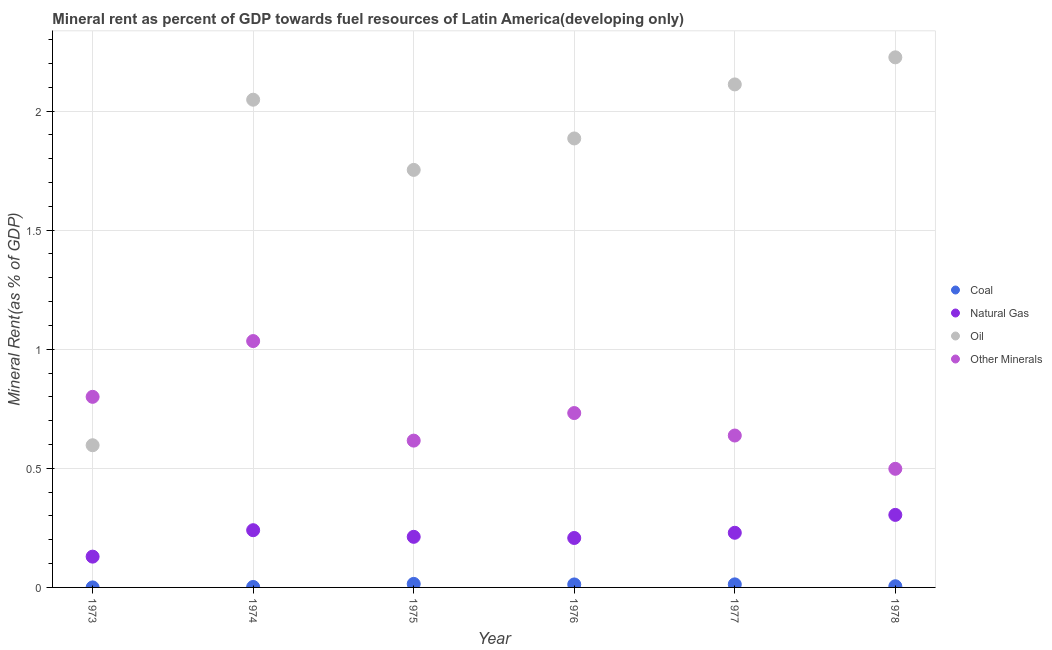Is the number of dotlines equal to the number of legend labels?
Provide a succinct answer. Yes. What is the oil rent in 1974?
Your response must be concise. 2.05. Across all years, what is the maximum  rent of other minerals?
Give a very brief answer. 1.03. Across all years, what is the minimum  rent of other minerals?
Ensure brevity in your answer.  0.5. In which year was the  rent of other minerals maximum?
Keep it short and to the point. 1974. In which year was the oil rent minimum?
Your answer should be compact. 1973. What is the total oil rent in the graph?
Keep it short and to the point. 10.62. What is the difference between the oil rent in 1976 and that in 1977?
Your response must be concise. -0.23. What is the difference between the coal rent in 1978 and the oil rent in 1973?
Ensure brevity in your answer.  -0.59. What is the average oil rent per year?
Keep it short and to the point. 1.77. In the year 1973, what is the difference between the  rent of other minerals and natural gas rent?
Offer a terse response. 0.67. In how many years, is the coal rent greater than 0.8 %?
Your answer should be compact. 0. What is the ratio of the oil rent in 1974 to that in 1976?
Provide a succinct answer. 1.09. Is the  rent of other minerals in 1976 less than that in 1977?
Your answer should be very brief. No. Is the difference between the natural gas rent in 1976 and 1977 greater than the difference between the oil rent in 1976 and 1977?
Offer a terse response. Yes. What is the difference between the highest and the second highest oil rent?
Provide a succinct answer. 0.11. What is the difference between the highest and the lowest natural gas rent?
Your response must be concise. 0.18. In how many years, is the  rent of other minerals greater than the average  rent of other minerals taken over all years?
Offer a very short reply. 3. Is the sum of the natural gas rent in 1976 and 1977 greater than the maximum coal rent across all years?
Offer a terse response. Yes. Is it the case that in every year, the sum of the coal rent and natural gas rent is greater than the oil rent?
Offer a very short reply. No. Does the  rent of other minerals monotonically increase over the years?
Your response must be concise. No. How many dotlines are there?
Offer a terse response. 4. Does the graph contain any zero values?
Offer a terse response. No. Where does the legend appear in the graph?
Make the answer very short. Center right. How are the legend labels stacked?
Offer a very short reply. Vertical. What is the title of the graph?
Ensure brevity in your answer.  Mineral rent as percent of GDP towards fuel resources of Latin America(developing only). What is the label or title of the X-axis?
Ensure brevity in your answer.  Year. What is the label or title of the Y-axis?
Make the answer very short. Mineral Rent(as % of GDP). What is the Mineral Rent(as % of GDP) in Coal in 1973?
Give a very brief answer. 2.93770621847752e-5. What is the Mineral Rent(as % of GDP) in Natural Gas in 1973?
Your response must be concise. 0.13. What is the Mineral Rent(as % of GDP) in Oil in 1973?
Ensure brevity in your answer.  0.6. What is the Mineral Rent(as % of GDP) in Other Minerals in 1973?
Offer a very short reply. 0.8. What is the Mineral Rent(as % of GDP) of Coal in 1974?
Ensure brevity in your answer.  0. What is the Mineral Rent(as % of GDP) in Natural Gas in 1974?
Provide a succinct answer. 0.24. What is the Mineral Rent(as % of GDP) of Oil in 1974?
Make the answer very short. 2.05. What is the Mineral Rent(as % of GDP) of Other Minerals in 1974?
Give a very brief answer. 1.03. What is the Mineral Rent(as % of GDP) in Coal in 1975?
Your response must be concise. 0.01. What is the Mineral Rent(as % of GDP) in Natural Gas in 1975?
Ensure brevity in your answer.  0.21. What is the Mineral Rent(as % of GDP) of Oil in 1975?
Provide a succinct answer. 1.75. What is the Mineral Rent(as % of GDP) in Other Minerals in 1975?
Provide a succinct answer. 0.62. What is the Mineral Rent(as % of GDP) in Coal in 1976?
Keep it short and to the point. 0.01. What is the Mineral Rent(as % of GDP) in Natural Gas in 1976?
Give a very brief answer. 0.21. What is the Mineral Rent(as % of GDP) in Oil in 1976?
Your answer should be compact. 1.89. What is the Mineral Rent(as % of GDP) in Other Minerals in 1976?
Offer a terse response. 0.73. What is the Mineral Rent(as % of GDP) of Coal in 1977?
Ensure brevity in your answer.  0.01. What is the Mineral Rent(as % of GDP) of Natural Gas in 1977?
Your response must be concise. 0.23. What is the Mineral Rent(as % of GDP) in Oil in 1977?
Provide a succinct answer. 2.11. What is the Mineral Rent(as % of GDP) of Other Minerals in 1977?
Your answer should be compact. 0.64. What is the Mineral Rent(as % of GDP) in Coal in 1978?
Your answer should be compact. 0. What is the Mineral Rent(as % of GDP) in Natural Gas in 1978?
Keep it short and to the point. 0.3. What is the Mineral Rent(as % of GDP) of Oil in 1978?
Keep it short and to the point. 2.23. What is the Mineral Rent(as % of GDP) of Other Minerals in 1978?
Offer a very short reply. 0.5. Across all years, what is the maximum Mineral Rent(as % of GDP) in Coal?
Your answer should be compact. 0.01. Across all years, what is the maximum Mineral Rent(as % of GDP) in Natural Gas?
Provide a succinct answer. 0.3. Across all years, what is the maximum Mineral Rent(as % of GDP) of Oil?
Make the answer very short. 2.23. Across all years, what is the maximum Mineral Rent(as % of GDP) in Other Minerals?
Offer a very short reply. 1.03. Across all years, what is the minimum Mineral Rent(as % of GDP) in Coal?
Your answer should be compact. 2.93770621847752e-5. Across all years, what is the minimum Mineral Rent(as % of GDP) in Natural Gas?
Offer a terse response. 0.13. Across all years, what is the minimum Mineral Rent(as % of GDP) of Oil?
Your answer should be very brief. 0.6. Across all years, what is the minimum Mineral Rent(as % of GDP) in Other Minerals?
Provide a short and direct response. 0.5. What is the total Mineral Rent(as % of GDP) in Coal in the graph?
Ensure brevity in your answer.  0.05. What is the total Mineral Rent(as % of GDP) of Natural Gas in the graph?
Offer a terse response. 1.32. What is the total Mineral Rent(as % of GDP) of Oil in the graph?
Give a very brief answer. 10.62. What is the total Mineral Rent(as % of GDP) of Other Minerals in the graph?
Your answer should be very brief. 4.32. What is the difference between the Mineral Rent(as % of GDP) of Coal in 1973 and that in 1974?
Provide a short and direct response. -0. What is the difference between the Mineral Rent(as % of GDP) of Natural Gas in 1973 and that in 1974?
Make the answer very short. -0.11. What is the difference between the Mineral Rent(as % of GDP) of Oil in 1973 and that in 1974?
Make the answer very short. -1.45. What is the difference between the Mineral Rent(as % of GDP) in Other Minerals in 1973 and that in 1974?
Make the answer very short. -0.23. What is the difference between the Mineral Rent(as % of GDP) of Coal in 1973 and that in 1975?
Your answer should be compact. -0.01. What is the difference between the Mineral Rent(as % of GDP) of Natural Gas in 1973 and that in 1975?
Give a very brief answer. -0.08. What is the difference between the Mineral Rent(as % of GDP) of Oil in 1973 and that in 1975?
Keep it short and to the point. -1.16. What is the difference between the Mineral Rent(as % of GDP) of Other Minerals in 1973 and that in 1975?
Give a very brief answer. 0.18. What is the difference between the Mineral Rent(as % of GDP) of Coal in 1973 and that in 1976?
Make the answer very short. -0.01. What is the difference between the Mineral Rent(as % of GDP) in Natural Gas in 1973 and that in 1976?
Your answer should be very brief. -0.08. What is the difference between the Mineral Rent(as % of GDP) in Oil in 1973 and that in 1976?
Give a very brief answer. -1.29. What is the difference between the Mineral Rent(as % of GDP) in Other Minerals in 1973 and that in 1976?
Offer a very short reply. 0.07. What is the difference between the Mineral Rent(as % of GDP) in Coal in 1973 and that in 1977?
Give a very brief answer. -0.01. What is the difference between the Mineral Rent(as % of GDP) of Natural Gas in 1973 and that in 1977?
Make the answer very short. -0.1. What is the difference between the Mineral Rent(as % of GDP) of Oil in 1973 and that in 1977?
Ensure brevity in your answer.  -1.51. What is the difference between the Mineral Rent(as % of GDP) of Other Minerals in 1973 and that in 1977?
Your answer should be compact. 0.16. What is the difference between the Mineral Rent(as % of GDP) of Coal in 1973 and that in 1978?
Ensure brevity in your answer.  -0. What is the difference between the Mineral Rent(as % of GDP) of Natural Gas in 1973 and that in 1978?
Keep it short and to the point. -0.18. What is the difference between the Mineral Rent(as % of GDP) in Oil in 1973 and that in 1978?
Keep it short and to the point. -1.63. What is the difference between the Mineral Rent(as % of GDP) of Other Minerals in 1973 and that in 1978?
Make the answer very short. 0.3. What is the difference between the Mineral Rent(as % of GDP) in Coal in 1974 and that in 1975?
Provide a short and direct response. -0.01. What is the difference between the Mineral Rent(as % of GDP) of Natural Gas in 1974 and that in 1975?
Offer a very short reply. 0.03. What is the difference between the Mineral Rent(as % of GDP) of Oil in 1974 and that in 1975?
Give a very brief answer. 0.29. What is the difference between the Mineral Rent(as % of GDP) of Other Minerals in 1974 and that in 1975?
Give a very brief answer. 0.42. What is the difference between the Mineral Rent(as % of GDP) of Coal in 1974 and that in 1976?
Your answer should be very brief. -0.01. What is the difference between the Mineral Rent(as % of GDP) in Natural Gas in 1974 and that in 1976?
Provide a succinct answer. 0.03. What is the difference between the Mineral Rent(as % of GDP) in Oil in 1974 and that in 1976?
Keep it short and to the point. 0.16. What is the difference between the Mineral Rent(as % of GDP) in Other Minerals in 1974 and that in 1976?
Keep it short and to the point. 0.3. What is the difference between the Mineral Rent(as % of GDP) of Coal in 1974 and that in 1977?
Offer a terse response. -0.01. What is the difference between the Mineral Rent(as % of GDP) in Natural Gas in 1974 and that in 1977?
Your response must be concise. 0.01. What is the difference between the Mineral Rent(as % of GDP) in Oil in 1974 and that in 1977?
Keep it short and to the point. -0.06. What is the difference between the Mineral Rent(as % of GDP) in Other Minerals in 1974 and that in 1977?
Your answer should be compact. 0.4. What is the difference between the Mineral Rent(as % of GDP) of Coal in 1974 and that in 1978?
Make the answer very short. -0. What is the difference between the Mineral Rent(as % of GDP) of Natural Gas in 1974 and that in 1978?
Your answer should be compact. -0.06. What is the difference between the Mineral Rent(as % of GDP) in Oil in 1974 and that in 1978?
Ensure brevity in your answer.  -0.18. What is the difference between the Mineral Rent(as % of GDP) of Other Minerals in 1974 and that in 1978?
Make the answer very short. 0.54. What is the difference between the Mineral Rent(as % of GDP) in Coal in 1975 and that in 1976?
Offer a terse response. 0. What is the difference between the Mineral Rent(as % of GDP) of Natural Gas in 1975 and that in 1976?
Provide a short and direct response. 0. What is the difference between the Mineral Rent(as % of GDP) in Oil in 1975 and that in 1976?
Your answer should be very brief. -0.13. What is the difference between the Mineral Rent(as % of GDP) in Other Minerals in 1975 and that in 1976?
Keep it short and to the point. -0.12. What is the difference between the Mineral Rent(as % of GDP) of Coal in 1975 and that in 1977?
Ensure brevity in your answer.  0. What is the difference between the Mineral Rent(as % of GDP) of Natural Gas in 1975 and that in 1977?
Keep it short and to the point. -0.02. What is the difference between the Mineral Rent(as % of GDP) in Oil in 1975 and that in 1977?
Give a very brief answer. -0.36. What is the difference between the Mineral Rent(as % of GDP) in Other Minerals in 1975 and that in 1977?
Your response must be concise. -0.02. What is the difference between the Mineral Rent(as % of GDP) in Coal in 1975 and that in 1978?
Your response must be concise. 0.01. What is the difference between the Mineral Rent(as % of GDP) in Natural Gas in 1975 and that in 1978?
Offer a very short reply. -0.09. What is the difference between the Mineral Rent(as % of GDP) in Oil in 1975 and that in 1978?
Your answer should be compact. -0.47. What is the difference between the Mineral Rent(as % of GDP) in Other Minerals in 1975 and that in 1978?
Offer a very short reply. 0.12. What is the difference between the Mineral Rent(as % of GDP) in Coal in 1976 and that in 1977?
Ensure brevity in your answer.  -0. What is the difference between the Mineral Rent(as % of GDP) in Natural Gas in 1976 and that in 1977?
Keep it short and to the point. -0.02. What is the difference between the Mineral Rent(as % of GDP) in Oil in 1976 and that in 1977?
Offer a very short reply. -0.23. What is the difference between the Mineral Rent(as % of GDP) of Other Minerals in 1976 and that in 1977?
Your answer should be compact. 0.09. What is the difference between the Mineral Rent(as % of GDP) in Coal in 1976 and that in 1978?
Provide a short and direct response. 0.01. What is the difference between the Mineral Rent(as % of GDP) of Natural Gas in 1976 and that in 1978?
Keep it short and to the point. -0.1. What is the difference between the Mineral Rent(as % of GDP) in Oil in 1976 and that in 1978?
Offer a very short reply. -0.34. What is the difference between the Mineral Rent(as % of GDP) in Other Minerals in 1976 and that in 1978?
Offer a very short reply. 0.23. What is the difference between the Mineral Rent(as % of GDP) in Coal in 1977 and that in 1978?
Offer a terse response. 0.01. What is the difference between the Mineral Rent(as % of GDP) in Natural Gas in 1977 and that in 1978?
Your response must be concise. -0.08. What is the difference between the Mineral Rent(as % of GDP) in Oil in 1977 and that in 1978?
Provide a succinct answer. -0.11. What is the difference between the Mineral Rent(as % of GDP) in Other Minerals in 1977 and that in 1978?
Your answer should be compact. 0.14. What is the difference between the Mineral Rent(as % of GDP) in Coal in 1973 and the Mineral Rent(as % of GDP) in Natural Gas in 1974?
Your answer should be compact. -0.24. What is the difference between the Mineral Rent(as % of GDP) in Coal in 1973 and the Mineral Rent(as % of GDP) in Oil in 1974?
Your answer should be very brief. -2.05. What is the difference between the Mineral Rent(as % of GDP) of Coal in 1973 and the Mineral Rent(as % of GDP) of Other Minerals in 1974?
Keep it short and to the point. -1.03. What is the difference between the Mineral Rent(as % of GDP) of Natural Gas in 1973 and the Mineral Rent(as % of GDP) of Oil in 1974?
Provide a short and direct response. -1.92. What is the difference between the Mineral Rent(as % of GDP) of Natural Gas in 1973 and the Mineral Rent(as % of GDP) of Other Minerals in 1974?
Provide a succinct answer. -0.91. What is the difference between the Mineral Rent(as % of GDP) of Oil in 1973 and the Mineral Rent(as % of GDP) of Other Minerals in 1974?
Provide a short and direct response. -0.44. What is the difference between the Mineral Rent(as % of GDP) of Coal in 1973 and the Mineral Rent(as % of GDP) of Natural Gas in 1975?
Give a very brief answer. -0.21. What is the difference between the Mineral Rent(as % of GDP) in Coal in 1973 and the Mineral Rent(as % of GDP) in Oil in 1975?
Give a very brief answer. -1.75. What is the difference between the Mineral Rent(as % of GDP) in Coal in 1973 and the Mineral Rent(as % of GDP) in Other Minerals in 1975?
Provide a succinct answer. -0.62. What is the difference between the Mineral Rent(as % of GDP) in Natural Gas in 1973 and the Mineral Rent(as % of GDP) in Oil in 1975?
Offer a very short reply. -1.62. What is the difference between the Mineral Rent(as % of GDP) in Natural Gas in 1973 and the Mineral Rent(as % of GDP) in Other Minerals in 1975?
Offer a terse response. -0.49. What is the difference between the Mineral Rent(as % of GDP) in Oil in 1973 and the Mineral Rent(as % of GDP) in Other Minerals in 1975?
Keep it short and to the point. -0.02. What is the difference between the Mineral Rent(as % of GDP) in Coal in 1973 and the Mineral Rent(as % of GDP) in Natural Gas in 1976?
Offer a very short reply. -0.21. What is the difference between the Mineral Rent(as % of GDP) in Coal in 1973 and the Mineral Rent(as % of GDP) in Oil in 1976?
Provide a short and direct response. -1.89. What is the difference between the Mineral Rent(as % of GDP) in Coal in 1973 and the Mineral Rent(as % of GDP) in Other Minerals in 1976?
Ensure brevity in your answer.  -0.73. What is the difference between the Mineral Rent(as % of GDP) of Natural Gas in 1973 and the Mineral Rent(as % of GDP) of Oil in 1976?
Make the answer very short. -1.76. What is the difference between the Mineral Rent(as % of GDP) in Natural Gas in 1973 and the Mineral Rent(as % of GDP) in Other Minerals in 1976?
Your response must be concise. -0.6. What is the difference between the Mineral Rent(as % of GDP) of Oil in 1973 and the Mineral Rent(as % of GDP) of Other Minerals in 1976?
Provide a succinct answer. -0.14. What is the difference between the Mineral Rent(as % of GDP) in Coal in 1973 and the Mineral Rent(as % of GDP) in Natural Gas in 1977?
Your response must be concise. -0.23. What is the difference between the Mineral Rent(as % of GDP) in Coal in 1973 and the Mineral Rent(as % of GDP) in Oil in 1977?
Your answer should be very brief. -2.11. What is the difference between the Mineral Rent(as % of GDP) of Coal in 1973 and the Mineral Rent(as % of GDP) of Other Minerals in 1977?
Offer a terse response. -0.64. What is the difference between the Mineral Rent(as % of GDP) of Natural Gas in 1973 and the Mineral Rent(as % of GDP) of Oil in 1977?
Provide a short and direct response. -1.98. What is the difference between the Mineral Rent(as % of GDP) of Natural Gas in 1973 and the Mineral Rent(as % of GDP) of Other Minerals in 1977?
Ensure brevity in your answer.  -0.51. What is the difference between the Mineral Rent(as % of GDP) of Oil in 1973 and the Mineral Rent(as % of GDP) of Other Minerals in 1977?
Your response must be concise. -0.04. What is the difference between the Mineral Rent(as % of GDP) of Coal in 1973 and the Mineral Rent(as % of GDP) of Natural Gas in 1978?
Provide a short and direct response. -0.3. What is the difference between the Mineral Rent(as % of GDP) of Coal in 1973 and the Mineral Rent(as % of GDP) of Oil in 1978?
Provide a succinct answer. -2.23. What is the difference between the Mineral Rent(as % of GDP) in Coal in 1973 and the Mineral Rent(as % of GDP) in Other Minerals in 1978?
Offer a very short reply. -0.5. What is the difference between the Mineral Rent(as % of GDP) of Natural Gas in 1973 and the Mineral Rent(as % of GDP) of Oil in 1978?
Your response must be concise. -2.1. What is the difference between the Mineral Rent(as % of GDP) in Natural Gas in 1973 and the Mineral Rent(as % of GDP) in Other Minerals in 1978?
Your answer should be very brief. -0.37. What is the difference between the Mineral Rent(as % of GDP) of Oil in 1973 and the Mineral Rent(as % of GDP) of Other Minerals in 1978?
Provide a short and direct response. 0.1. What is the difference between the Mineral Rent(as % of GDP) in Coal in 1974 and the Mineral Rent(as % of GDP) in Natural Gas in 1975?
Provide a short and direct response. -0.21. What is the difference between the Mineral Rent(as % of GDP) in Coal in 1974 and the Mineral Rent(as % of GDP) in Oil in 1975?
Your answer should be very brief. -1.75. What is the difference between the Mineral Rent(as % of GDP) in Coal in 1974 and the Mineral Rent(as % of GDP) in Other Minerals in 1975?
Ensure brevity in your answer.  -0.61. What is the difference between the Mineral Rent(as % of GDP) of Natural Gas in 1974 and the Mineral Rent(as % of GDP) of Oil in 1975?
Offer a very short reply. -1.51. What is the difference between the Mineral Rent(as % of GDP) in Natural Gas in 1974 and the Mineral Rent(as % of GDP) in Other Minerals in 1975?
Offer a very short reply. -0.38. What is the difference between the Mineral Rent(as % of GDP) of Oil in 1974 and the Mineral Rent(as % of GDP) of Other Minerals in 1975?
Give a very brief answer. 1.43. What is the difference between the Mineral Rent(as % of GDP) of Coal in 1974 and the Mineral Rent(as % of GDP) of Natural Gas in 1976?
Provide a short and direct response. -0.21. What is the difference between the Mineral Rent(as % of GDP) in Coal in 1974 and the Mineral Rent(as % of GDP) in Oil in 1976?
Give a very brief answer. -1.88. What is the difference between the Mineral Rent(as % of GDP) of Coal in 1974 and the Mineral Rent(as % of GDP) of Other Minerals in 1976?
Provide a succinct answer. -0.73. What is the difference between the Mineral Rent(as % of GDP) in Natural Gas in 1974 and the Mineral Rent(as % of GDP) in Oil in 1976?
Provide a succinct answer. -1.64. What is the difference between the Mineral Rent(as % of GDP) of Natural Gas in 1974 and the Mineral Rent(as % of GDP) of Other Minerals in 1976?
Your answer should be compact. -0.49. What is the difference between the Mineral Rent(as % of GDP) of Oil in 1974 and the Mineral Rent(as % of GDP) of Other Minerals in 1976?
Offer a terse response. 1.32. What is the difference between the Mineral Rent(as % of GDP) of Coal in 1974 and the Mineral Rent(as % of GDP) of Natural Gas in 1977?
Keep it short and to the point. -0.23. What is the difference between the Mineral Rent(as % of GDP) of Coal in 1974 and the Mineral Rent(as % of GDP) of Oil in 1977?
Your answer should be compact. -2.11. What is the difference between the Mineral Rent(as % of GDP) in Coal in 1974 and the Mineral Rent(as % of GDP) in Other Minerals in 1977?
Keep it short and to the point. -0.64. What is the difference between the Mineral Rent(as % of GDP) in Natural Gas in 1974 and the Mineral Rent(as % of GDP) in Oil in 1977?
Give a very brief answer. -1.87. What is the difference between the Mineral Rent(as % of GDP) in Natural Gas in 1974 and the Mineral Rent(as % of GDP) in Other Minerals in 1977?
Provide a short and direct response. -0.4. What is the difference between the Mineral Rent(as % of GDP) in Oil in 1974 and the Mineral Rent(as % of GDP) in Other Minerals in 1977?
Your answer should be very brief. 1.41. What is the difference between the Mineral Rent(as % of GDP) in Coal in 1974 and the Mineral Rent(as % of GDP) in Natural Gas in 1978?
Provide a short and direct response. -0.3. What is the difference between the Mineral Rent(as % of GDP) in Coal in 1974 and the Mineral Rent(as % of GDP) in Oil in 1978?
Provide a succinct answer. -2.22. What is the difference between the Mineral Rent(as % of GDP) in Coal in 1974 and the Mineral Rent(as % of GDP) in Other Minerals in 1978?
Your response must be concise. -0.5. What is the difference between the Mineral Rent(as % of GDP) in Natural Gas in 1974 and the Mineral Rent(as % of GDP) in Oil in 1978?
Offer a very short reply. -1.99. What is the difference between the Mineral Rent(as % of GDP) of Natural Gas in 1974 and the Mineral Rent(as % of GDP) of Other Minerals in 1978?
Provide a short and direct response. -0.26. What is the difference between the Mineral Rent(as % of GDP) in Oil in 1974 and the Mineral Rent(as % of GDP) in Other Minerals in 1978?
Offer a terse response. 1.55. What is the difference between the Mineral Rent(as % of GDP) of Coal in 1975 and the Mineral Rent(as % of GDP) of Natural Gas in 1976?
Make the answer very short. -0.19. What is the difference between the Mineral Rent(as % of GDP) in Coal in 1975 and the Mineral Rent(as % of GDP) in Oil in 1976?
Offer a very short reply. -1.87. What is the difference between the Mineral Rent(as % of GDP) in Coal in 1975 and the Mineral Rent(as % of GDP) in Other Minerals in 1976?
Your answer should be compact. -0.72. What is the difference between the Mineral Rent(as % of GDP) in Natural Gas in 1975 and the Mineral Rent(as % of GDP) in Oil in 1976?
Provide a succinct answer. -1.67. What is the difference between the Mineral Rent(as % of GDP) of Natural Gas in 1975 and the Mineral Rent(as % of GDP) of Other Minerals in 1976?
Offer a very short reply. -0.52. What is the difference between the Mineral Rent(as % of GDP) of Oil in 1975 and the Mineral Rent(as % of GDP) of Other Minerals in 1976?
Your response must be concise. 1.02. What is the difference between the Mineral Rent(as % of GDP) in Coal in 1975 and the Mineral Rent(as % of GDP) in Natural Gas in 1977?
Provide a short and direct response. -0.21. What is the difference between the Mineral Rent(as % of GDP) in Coal in 1975 and the Mineral Rent(as % of GDP) in Oil in 1977?
Give a very brief answer. -2.1. What is the difference between the Mineral Rent(as % of GDP) of Coal in 1975 and the Mineral Rent(as % of GDP) of Other Minerals in 1977?
Offer a terse response. -0.62. What is the difference between the Mineral Rent(as % of GDP) of Natural Gas in 1975 and the Mineral Rent(as % of GDP) of Oil in 1977?
Provide a short and direct response. -1.9. What is the difference between the Mineral Rent(as % of GDP) of Natural Gas in 1975 and the Mineral Rent(as % of GDP) of Other Minerals in 1977?
Your response must be concise. -0.43. What is the difference between the Mineral Rent(as % of GDP) in Oil in 1975 and the Mineral Rent(as % of GDP) in Other Minerals in 1977?
Provide a succinct answer. 1.12. What is the difference between the Mineral Rent(as % of GDP) in Coal in 1975 and the Mineral Rent(as % of GDP) in Natural Gas in 1978?
Give a very brief answer. -0.29. What is the difference between the Mineral Rent(as % of GDP) of Coal in 1975 and the Mineral Rent(as % of GDP) of Oil in 1978?
Offer a terse response. -2.21. What is the difference between the Mineral Rent(as % of GDP) in Coal in 1975 and the Mineral Rent(as % of GDP) in Other Minerals in 1978?
Your response must be concise. -0.48. What is the difference between the Mineral Rent(as % of GDP) of Natural Gas in 1975 and the Mineral Rent(as % of GDP) of Oil in 1978?
Offer a terse response. -2.01. What is the difference between the Mineral Rent(as % of GDP) of Natural Gas in 1975 and the Mineral Rent(as % of GDP) of Other Minerals in 1978?
Your answer should be very brief. -0.29. What is the difference between the Mineral Rent(as % of GDP) in Oil in 1975 and the Mineral Rent(as % of GDP) in Other Minerals in 1978?
Provide a succinct answer. 1.25. What is the difference between the Mineral Rent(as % of GDP) in Coal in 1976 and the Mineral Rent(as % of GDP) in Natural Gas in 1977?
Your response must be concise. -0.22. What is the difference between the Mineral Rent(as % of GDP) of Coal in 1976 and the Mineral Rent(as % of GDP) of Oil in 1977?
Make the answer very short. -2.1. What is the difference between the Mineral Rent(as % of GDP) in Coal in 1976 and the Mineral Rent(as % of GDP) in Other Minerals in 1977?
Give a very brief answer. -0.63. What is the difference between the Mineral Rent(as % of GDP) in Natural Gas in 1976 and the Mineral Rent(as % of GDP) in Oil in 1977?
Make the answer very short. -1.9. What is the difference between the Mineral Rent(as % of GDP) in Natural Gas in 1976 and the Mineral Rent(as % of GDP) in Other Minerals in 1977?
Your answer should be very brief. -0.43. What is the difference between the Mineral Rent(as % of GDP) in Oil in 1976 and the Mineral Rent(as % of GDP) in Other Minerals in 1977?
Make the answer very short. 1.25. What is the difference between the Mineral Rent(as % of GDP) in Coal in 1976 and the Mineral Rent(as % of GDP) in Natural Gas in 1978?
Give a very brief answer. -0.29. What is the difference between the Mineral Rent(as % of GDP) in Coal in 1976 and the Mineral Rent(as % of GDP) in Oil in 1978?
Make the answer very short. -2.21. What is the difference between the Mineral Rent(as % of GDP) in Coal in 1976 and the Mineral Rent(as % of GDP) in Other Minerals in 1978?
Offer a very short reply. -0.49. What is the difference between the Mineral Rent(as % of GDP) of Natural Gas in 1976 and the Mineral Rent(as % of GDP) of Oil in 1978?
Your answer should be very brief. -2.02. What is the difference between the Mineral Rent(as % of GDP) of Natural Gas in 1976 and the Mineral Rent(as % of GDP) of Other Minerals in 1978?
Offer a terse response. -0.29. What is the difference between the Mineral Rent(as % of GDP) of Oil in 1976 and the Mineral Rent(as % of GDP) of Other Minerals in 1978?
Give a very brief answer. 1.39. What is the difference between the Mineral Rent(as % of GDP) in Coal in 1977 and the Mineral Rent(as % of GDP) in Natural Gas in 1978?
Offer a very short reply. -0.29. What is the difference between the Mineral Rent(as % of GDP) of Coal in 1977 and the Mineral Rent(as % of GDP) of Oil in 1978?
Your answer should be compact. -2.21. What is the difference between the Mineral Rent(as % of GDP) in Coal in 1977 and the Mineral Rent(as % of GDP) in Other Minerals in 1978?
Offer a terse response. -0.49. What is the difference between the Mineral Rent(as % of GDP) of Natural Gas in 1977 and the Mineral Rent(as % of GDP) of Oil in 1978?
Provide a succinct answer. -2. What is the difference between the Mineral Rent(as % of GDP) in Natural Gas in 1977 and the Mineral Rent(as % of GDP) in Other Minerals in 1978?
Offer a terse response. -0.27. What is the difference between the Mineral Rent(as % of GDP) of Oil in 1977 and the Mineral Rent(as % of GDP) of Other Minerals in 1978?
Your answer should be compact. 1.61. What is the average Mineral Rent(as % of GDP) in Coal per year?
Your answer should be very brief. 0.01. What is the average Mineral Rent(as % of GDP) of Natural Gas per year?
Your answer should be compact. 0.22. What is the average Mineral Rent(as % of GDP) in Oil per year?
Give a very brief answer. 1.77. What is the average Mineral Rent(as % of GDP) in Other Minerals per year?
Keep it short and to the point. 0.72. In the year 1973, what is the difference between the Mineral Rent(as % of GDP) of Coal and Mineral Rent(as % of GDP) of Natural Gas?
Your answer should be compact. -0.13. In the year 1973, what is the difference between the Mineral Rent(as % of GDP) of Coal and Mineral Rent(as % of GDP) of Oil?
Offer a terse response. -0.6. In the year 1973, what is the difference between the Mineral Rent(as % of GDP) in Coal and Mineral Rent(as % of GDP) in Other Minerals?
Your answer should be compact. -0.8. In the year 1973, what is the difference between the Mineral Rent(as % of GDP) of Natural Gas and Mineral Rent(as % of GDP) of Oil?
Keep it short and to the point. -0.47. In the year 1973, what is the difference between the Mineral Rent(as % of GDP) in Natural Gas and Mineral Rent(as % of GDP) in Other Minerals?
Offer a terse response. -0.67. In the year 1973, what is the difference between the Mineral Rent(as % of GDP) in Oil and Mineral Rent(as % of GDP) in Other Minerals?
Provide a succinct answer. -0.2. In the year 1974, what is the difference between the Mineral Rent(as % of GDP) of Coal and Mineral Rent(as % of GDP) of Natural Gas?
Make the answer very short. -0.24. In the year 1974, what is the difference between the Mineral Rent(as % of GDP) of Coal and Mineral Rent(as % of GDP) of Oil?
Provide a succinct answer. -2.05. In the year 1974, what is the difference between the Mineral Rent(as % of GDP) in Coal and Mineral Rent(as % of GDP) in Other Minerals?
Offer a terse response. -1.03. In the year 1974, what is the difference between the Mineral Rent(as % of GDP) of Natural Gas and Mineral Rent(as % of GDP) of Oil?
Make the answer very short. -1.81. In the year 1974, what is the difference between the Mineral Rent(as % of GDP) of Natural Gas and Mineral Rent(as % of GDP) of Other Minerals?
Offer a terse response. -0.79. In the year 1974, what is the difference between the Mineral Rent(as % of GDP) in Oil and Mineral Rent(as % of GDP) in Other Minerals?
Keep it short and to the point. 1.01. In the year 1975, what is the difference between the Mineral Rent(as % of GDP) of Coal and Mineral Rent(as % of GDP) of Natural Gas?
Ensure brevity in your answer.  -0.2. In the year 1975, what is the difference between the Mineral Rent(as % of GDP) in Coal and Mineral Rent(as % of GDP) in Oil?
Your response must be concise. -1.74. In the year 1975, what is the difference between the Mineral Rent(as % of GDP) of Coal and Mineral Rent(as % of GDP) of Other Minerals?
Provide a succinct answer. -0.6. In the year 1975, what is the difference between the Mineral Rent(as % of GDP) of Natural Gas and Mineral Rent(as % of GDP) of Oil?
Offer a terse response. -1.54. In the year 1975, what is the difference between the Mineral Rent(as % of GDP) in Natural Gas and Mineral Rent(as % of GDP) in Other Minerals?
Your response must be concise. -0.4. In the year 1975, what is the difference between the Mineral Rent(as % of GDP) of Oil and Mineral Rent(as % of GDP) of Other Minerals?
Give a very brief answer. 1.14. In the year 1976, what is the difference between the Mineral Rent(as % of GDP) of Coal and Mineral Rent(as % of GDP) of Natural Gas?
Provide a succinct answer. -0.2. In the year 1976, what is the difference between the Mineral Rent(as % of GDP) in Coal and Mineral Rent(as % of GDP) in Oil?
Keep it short and to the point. -1.87. In the year 1976, what is the difference between the Mineral Rent(as % of GDP) in Coal and Mineral Rent(as % of GDP) in Other Minerals?
Your answer should be very brief. -0.72. In the year 1976, what is the difference between the Mineral Rent(as % of GDP) of Natural Gas and Mineral Rent(as % of GDP) of Oil?
Provide a short and direct response. -1.68. In the year 1976, what is the difference between the Mineral Rent(as % of GDP) in Natural Gas and Mineral Rent(as % of GDP) in Other Minerals?
Provide a succinct answer. -0.52. In the year 1976, what is the difference between the Mineral Rent(as % of GDP) of Oil and Mineral Rent(as % of GDP) of Other Minerals?
Your answer should be compact. 1.15. In the year 1977, what is the difference between the Mineral Rent(as % of GDP) of Coal and Mineral Rent(as % of GDP) of Natural Gas?
Provide a short and direct response. -0.22. In the year 1977, what is the difference between the Mineral Rent(as % of GDP) of Coal and Mineral Rent(as % of GDP) of Oil?
Provide a short and direct response. -2.1. In the year 1977, what is the difference between the Mineral Rent(as % of GDP) in Coal and Mineral Rent(as % of GDP) in Other Minerals?
Provide a succinct answer. -0.62. In the year 1977, what is the difference between the Mineral Rent(as % of GDP) in Natural Gas and Mineral Rent(as % of GDP) in Oil?
Ensure brevity in your answer.  -1.88. In the year 1977, what is the difference between the Mineral Rent(as % of GDP) of Natural Gas and Mineral Rent(as % of GDP) of Other Minerals?
Offer a terse response. -0.41. In the year 1977, what is the difference between the Mineral Rent(as % of GDP) in Oil and Mineral Rent(as % of GDP) in Other Minerals?
Your answer should be very brief. 1.47. In the year 1978, what is the difference between the Mineral Rent(as % of GDP) of Coal and Mineral Rent(as % of GDP) of Natural Gas?
Ensure brevity in your answer.  -0.3. In the year 1978, what is the difference between the Mineral Rent(as % of GDP) of Coal and Mineral Rent(as % of GDP) of Oil?
Ensure brevity in your answer.  -2.22. In the year 1978, what is the difference between the Mineral Rent(as % of GDP) of Coal and Mineral Rent(as % of GDP) of Other Minerals?
Give a very brief answer. -0.49. In the year 1978, what is the difference between the Mineral Rent(as % of GDP) in Natural Gas and Mineral Rent(as % of GDP) in Oil?
Your answer should be very brief. -1.92. In the year 1978, what is the difference between the Mineral Rent(as % of GDP) of Natural Gas and Mineral Rent(as % of GDP) of Other Minerals?
Give a very brief answer. -0.19. In the year 1978, what is the difference between the Mineral Rent(as % of GDP) in Oil and Mineral Rent(as % of GDP) in Other Minerals?
Provide a succinct answer. 1.73. What is the ratio of the Mineral Rent(as % of GDP) in Coal in 1973 to that in 1974?
Keep it short and to the point. 0.02. What is the ratio of the Mineral Rent(as % of GDP) in Natural Gas in 1973 to that in 1974?
Provide a succinct answer. 0.54. What is the ratio of the Mineral Rent(as % of GDP) of Oil in 1973 to that in 1974?
Ensure brevity in your answer.  0.29. What is the ratio of the Mineral Rent(as % of GDP) in Other Minerals in 1973 to that in 1974?
Your response must be concise. 0.77. What is the ratio of the Mineral Rent(as % of GDP) of Coal in 1973 to that in 1975?
Offer a very short reply. 0. What is the ratio of the Mineral Rent(as % of GDP) of Natural Gas in 1973 to that in 1975?
Provide a short and direct response. 0.61. What is the ratio of the Mineral Rent(as % of GDP) in Oil in 1973 to that in 1975?
Make the answer very short. 0.34. What is the ratio of the Mineral Rent(as % of GDP) of Other Minerals in 1973 to that in 1975?
Offer a very short reply. 1.3. What is the ratio of the Mineral Rent(as % of GDP) of Coal in 1973 to that in 1976?
Keep it short and to the point. 0. What is the ratio of the Mineral Rent(as % of GDP) of Natural Gas in 1973 to that in 1976?
Provide a succinct answer. 0.62. What is the ratio of the Mineral Rent(as % of GDP) in Oil in 1973 to that in 1976?
Your answer should be very brief. 0.32. What is the ratio of the Mineral Rent(as % of GDP) of Other Minerals in 1973 to that in 1976?
Offer a terse response. 1.09. What is the ratio of the Mineral Rent(as % of GDP) in Coal in 1973 to that in 1977?
Offer a terse response. 0. What is the ratio of the Mineral Rent(as % of GDP) of Natural Gas in 1973 to that in 1977?
Offer a terse response. 0.56. What is the ratio of the Mineral Rent(as % of GDP) in Oil in 1973 to that in 1977?
Your answer should be compact. 0.28. What is the ratio of the Mineral Rent(as % of GDP) in Other Minerals in 1973 to that in 1977?
Offer a terse response. 1.25. What is the ratio of the Mineral Rent(as % of GDP) in Coal in 1973 to that in 1978?
Make the answer very short. 0.01. What is the ratio of the Mineral Rent(as % of GDP) of Natural Gas in 1973 to that in 1978?
Give a very brief answer. 0.42. What is the ratio of the Mineral Rent(as % of GDP) of Oil in 1973 to that in 1978?
Your answer should be very brief. 0.27. What is the ratio of the Mineral Rent(as % of GDP) of Other Minerals in 1973 to that in 1978?
Make the answer very short. 1.61. What is the ratio of the Mineral Rent(as % of GDP) of Coal in 1974 to that in 1975?
Your answer should be very brief. 0.13. What is the ratio of the Mineral Rent(as % of GDP) of Natural Gas in 1974 to that in 1975?
Your answer should be compact. 1.13. What is the ratio of the Mineral Rent(as % of GDP) in Oil in 1974 to that in 1975?
Your answer should be very brief. 1.17. What is the ratio of the Mineral Rent(as % of GDP) of Other Minerals in 1974 to that in 1975?
Your response must be concise. 1.68. What is the ratio of the Mineral Rent(as % of GDP) in Coal in 1974 to that in 1976?
Offer a terse response. 0.15. What is the ratio of the Mineral Rent(as % of GDP) of Natural Gas in 1974 to that in 1976?
Provide a short and direct response. 1.16. What is the ratio of the Mineral Rent(as % of GDP) of Oil in 1974 to that in 1976?
Provide a succinct answer. 1.09. What is the ratio of the Mineral Rent(as % of GDP) in Other Minerals in 1974 to that in 1976?
Provide a succinct answer. 1.41. What is the ratio of the Mineral Rent(as % of GDP) of Coal in 1974 to that in 1977?
Offer a terse response. 0.15. What is the ratio of the Mineral Rent(as % of GDP) of Natural Gas in 1974 to that in 1977?
Your answer should be very brief. 1.05. What is the ratio of the Mineral Rent(as % of GDP) in Oil in 1974 to that in 1977?
Your answer should be compact. 0.97. What is the ratio of the Mineral Rent(as % of GDP) of Other Minerals in 1974 to that in 1977?
Make the answer very short. 1.62. What is the ratio of the Mineral Rent(as % of GDP) of Coal in 1974 to that in 1978?
Provide a succinct answer. 0.39. What is the ratio of the Mineral Rent(as % of GDP) in Natural Gas in 1974 to that in 1978?
Give a very brief answer. 0.79. What is the ratio of the Mineral Rent(as % of GDP) in Oil in 1974 to that in 1978?
Provide a succinct answer. 0.92. What is the ratio of the Mineral Rent(as % of GDP) of Other Minerals in 1974 to that in 1978?
Your answer should be very brief. 2.08. What is the ratio of the Mineral Rent(as % of GDP) of Coal in 1975 to that in 1976?
Offer a very short reply. 1.18. What is the ratio of the Mineral Rent(as % of GDP) of Natural Gas in 1975 to that in 1976?
Give a very brief answer. 1.02. What is the ratio of the Mineral Rent(as % of GDP) in Oil in 1975 to that in 1976?
Provide a succinct answer. 0.93. What is the ratio of the Mineral Rent(as % of GDP) of Other Minerals in 1975 to that in 1976?
Offer a very short reply. 0.84. What is the ratio of the Mineral Rent(as % of GDP) in Coal in 1975 to that in 1977?
Your response must be concise. 1.15. What is the ratio of the Mineral Rent(as % of GDP) in Natural Gas in 1975 to that in 1977?
Ensure brevity in your answer.  0.93. What is the ratio of the Mineral Rent(as % of GDP) in Oil in 1975 to that in 1977?
Give a very brief answer. 0.83. What is the ratio of the Mineral Rent(as % of GDP) of Other Minerals in 1975 to that in 1977?
Make the answer very short. 0.97. What is the ratio of the Mineral Rent(as % of GDP) of Coal in 1975 to that in 1978?
Keep it short and to the point. 3. What is the ratio of the Mineral Rent(as % of GDP) in Natural Gas in 1975 to that in 1978?
Offer a very short reply. 0.7. What is the ratio of the Mineral Rent(as % of GDP) in Oil in 1975 to that in 1978?
Your answer should be very brief. 0.79. What is the ratio of the Mineral Rent(as % of GDP) of Other Minerals in 1975 to that in 1978?
Your response must be concise. 1.24. What is the ratio of the Mineral Rent(as % of GDP) of Coal in 1976 to that in 1977?
Offer a very short reply. 0.98. What is the ratio of the Mineral Rent(as % of GDP) of Natural Gas in 1976 to that in 1977?
Your answer should be compact. 0.9. What is the ratio of the Mineral Rent(as % of GDP) in Oil in 1976 to that in 1977?
Offer a very short reply. 0.89. What is the ratio of the Mineral Rent(as % of GDP) of Other Minerals in 1976 to that in 1977?
Provide a succinct answer. 1.15. What is the ratio of the Mineral Rent(as % of GDP) of Coal in 1976 to that in 1978?
Your answer should be very brief. 2.55. What is the ratio of the Mineral Rent(as % of GDP) in Natural Gas in 1976 to that in 1978?
Keep it short and to the point. 0.68. What is the ratio of the Mineral Rent(as % of GDP) in Oil in 1976 to that in 1978?
Your answer should be very brief. 0.85. What is the ratio of the Mineral Rent(as % of GDP) of Other Minerals in 1976 to that in 1978?
Provide a short and direct response. 1.47. What is the ratio of the Mineral Rent(as % of GDP) in Coal in 1977 to that in 1978?
Your answer should be compact. 2.6. What is the ratio of the Mineral Rent(as % of GDP) in Natural Gas in 1977 to that in 1978?
Offer a very short reply. 0.75. What is the ratio of the Mineral Rent(as % of GDP) of Oil in 1977 to that in 1978?
Make the answer very short. 0.95. What is the ratio of the Mineral Rent(as % of GDP) of Other Minerals in 1977 to that in 1978?
Your response must be concise. 1.28. What is the difference between the highest and the second highest Mineral Rent(as % of GDP) in Coal?
Offer a very short reply. 0. What is the difference between the highest and the second highest Mineral Rent(as % of GDP) in Natural Gas?
Offer a terse response. 0.06. What is the difference between the highest and the second highest Mineral Rent(as % of GDP) of Oil?
Your answer should be very brief. 0.11. What is the difference between the highest and the second highest Mineral Rent(as % of GDP) in Other Minerals?
Keep it short and to the point. 0.23. What is the difference between the highest and the lowest Mineral Rent(as % of GDP) of Coal?
Give a very brief answer. 0.01. What is the difference between the highest and the lowest Mineral Rent(as % of GDP) in Natural Gas?
Your answer should be compact. 0.18. What is the difference between the highest and the lowest Mineral Rent(as % of GDP) in Oil?
Make the answer very short. 1.63. What is the difference between the highest and the lowest Mineral Rent(as % of GDP) in Other Minerals?
Make the answer very short. 0.54. 